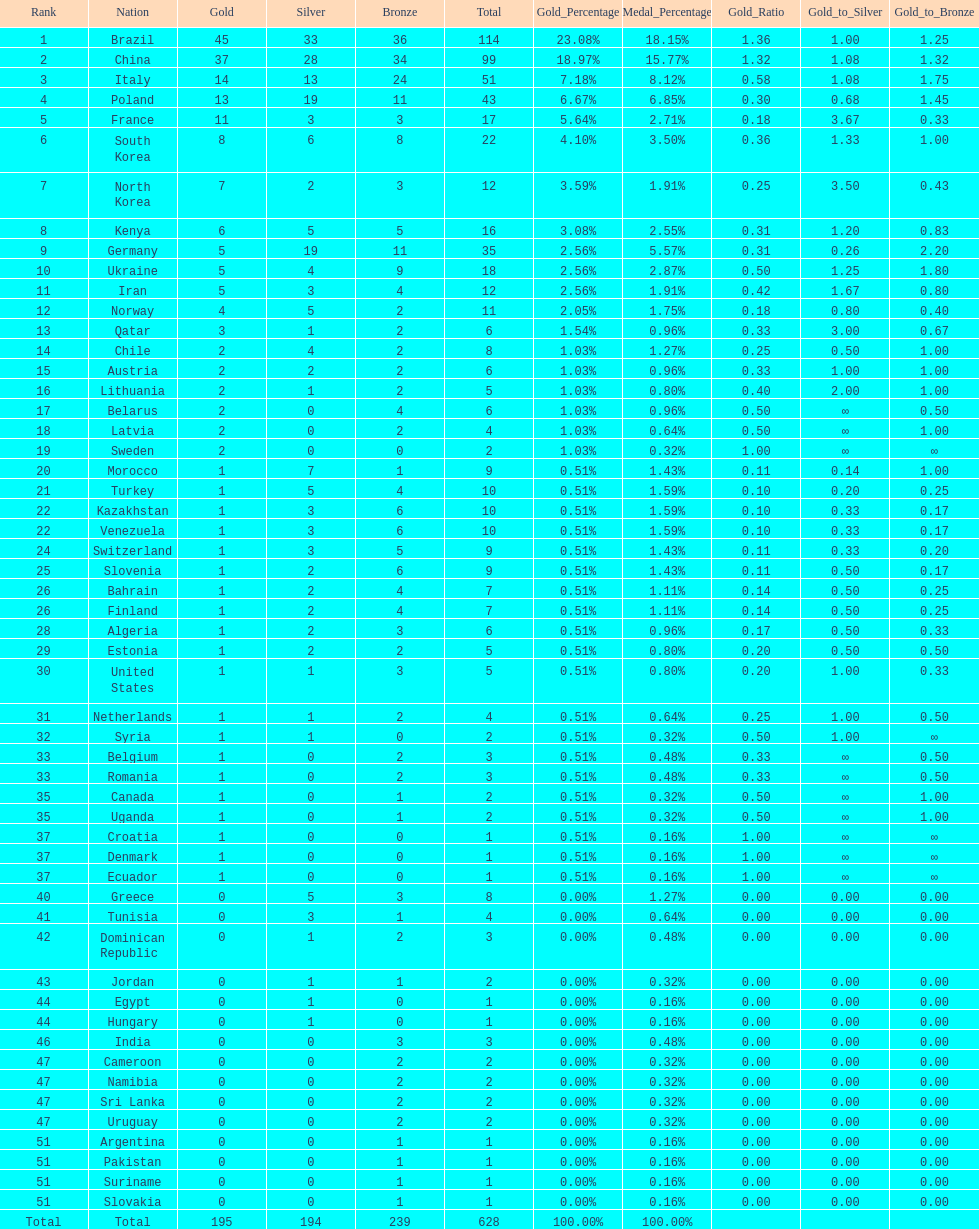How many more gold medals does china have over france? 26. 